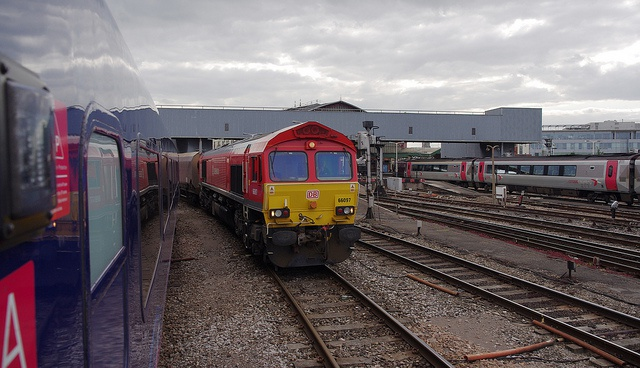Describe the objects in this image and their specific colors. I can see train in gray, black, and darkgray tones, train in gray, black, maroon, and olive tones, and train in gray, black, and maroon tones in this image. 